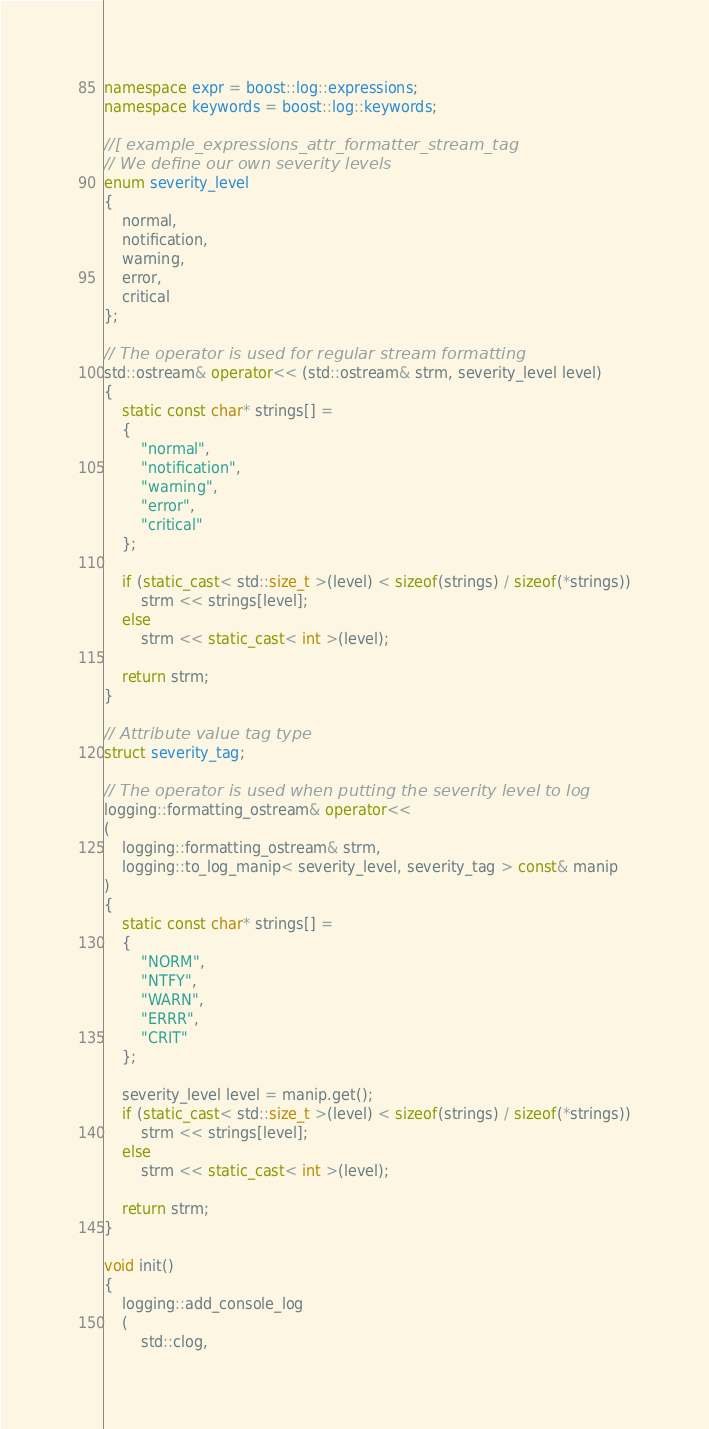<code> <loc_0><loc_0><loc_500><loc_500><_C++_>namespace expr = boost::log::expressions;
namespace keywords = boost::log::keywords;

//[ example_expressions_attr_formatter_stream_tag
// We define our own severity levels
enum severity_level
{
    normal,
    notification,
    warning,
    error,
    critical
};

// The operator is used for regular stream formatting
std::ostream& operator<< (std::ostream& strm, severity_level level)
{
    static const char* strings[] =
    {
        "normal",
        "notification",
        "warning",
        "error",
        "critical"
    };

    if (static_cast< std::size_t >(level) < sizeof(strings) / sizeof(*strings))
        strm << strings[level];
    else
        strm << static_cast< int >(level);

    return strm;
}

// Attribute value tag type
struct severity_tag;

// The operator is used when putting the severity level to log
logging::formatting_ostream& operator<<
(
    logging::formatting_ostream& strm,
    logging::to_log_manip< severity_level, severity_tag > const& manip
)
{
    static const char* strings[] =
    {
        "NORM",
        "NTFY",
        "WARN",
        "ERRR",
        "CRIT"
    };

    severity_level level = manip.get();
    if (static_cast< std::size_t >(level) < sizeof(strings) / sizeof(*strings))
        strm << strings[level];
    else
        strm << static_cast< int >(level);

    return strm;
}

void init()
{
    logging::add_console_log
    (
        std::clog,</code> 